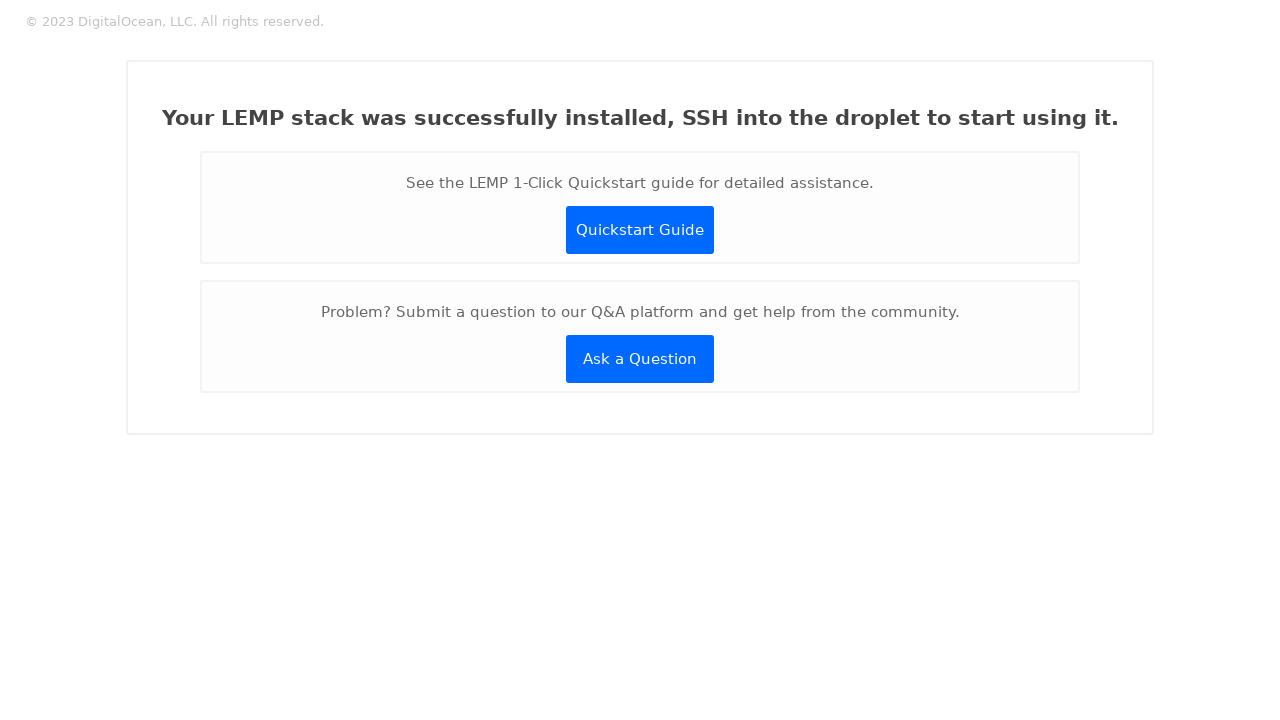Could you detail the process for assembling this website using HTML? <html>
 <head>
  <style>
   body {
        font-family: ProximaNova;
        font-size: 15px;
        font-style: normal;
        font-stretch: normal;
        line-height: 1;
        letter-spacing: normal;
        margin: 0;
      }

      .button {
        border-radius: 3px;
        background-color: #0069ff;
        color: #ffffff;
        display: flex;
        flex-direction: column;
        height: 48px;
        justify-content: center;
        text-decoration: none;
        width: 148px;
      }

      .content {
        align-items: center;
        border: solid 2px #f1f1f1;
        border-radius: 3px;
        display: flex;
        flex-direction: column;
        margin: 32px auto;
        padding: 32px;
        text-align: center;
        width: 960px;
      }
      
      .content_min {
        align-items: center;
        border: solid 2px #f3f3f3;
        background-color: #fdfdfd;
        border-radius: 3px;
        display: flex;
        flex-direction: column;
        margin: 8px auto;
        padding: 8px;
        text-align: center;
        width: 860px;
      }

      .copyright {
        color: #99999999;
        font-size: 13px;
        margin-left: 10px;
      }

      .description {
        color: #676767;
      }

      .empty-access {
        height: 220px;
        margin-bottom: -20px;
      }

      .header {
        align-items: center;
        display: flex;
        margin: 15px;
      }

      .logo {
        height: 30px;
        color: #999999;
        width: 30px;
      }

      .title {
        font-family: ProximaNova;
        font-size: 21px;
        font-weight: 600;
        color: #444444;
      }
  </style>
 </head>
 <body>
  <div class="header">
   <div class="copyright">
    &copy; 2023 DigitalOcean, LLC. All rights reserved.
   </div>
  </div>
  <div class="content">
   <h1 class="title">
    Your LEMP stack was successfully installed, SSH into the droplet to start using it.
   </h1>
   <div class="content_min">
    <p class="description">
     See the LEMP 1-Click Quickstart guide for detailed assistance.
    </p>
    <a class="button">
     Quickstart Guide
    </a>
   </div>
   <div class="content_min">
    <p class="description">
     Problem? Submit a question to our Q&amp;A platform and get help from the community.
    </p>
    <a class="button">
     Ask a Question
    </a>
   </div>
  </div>
 </body>
</html>
 